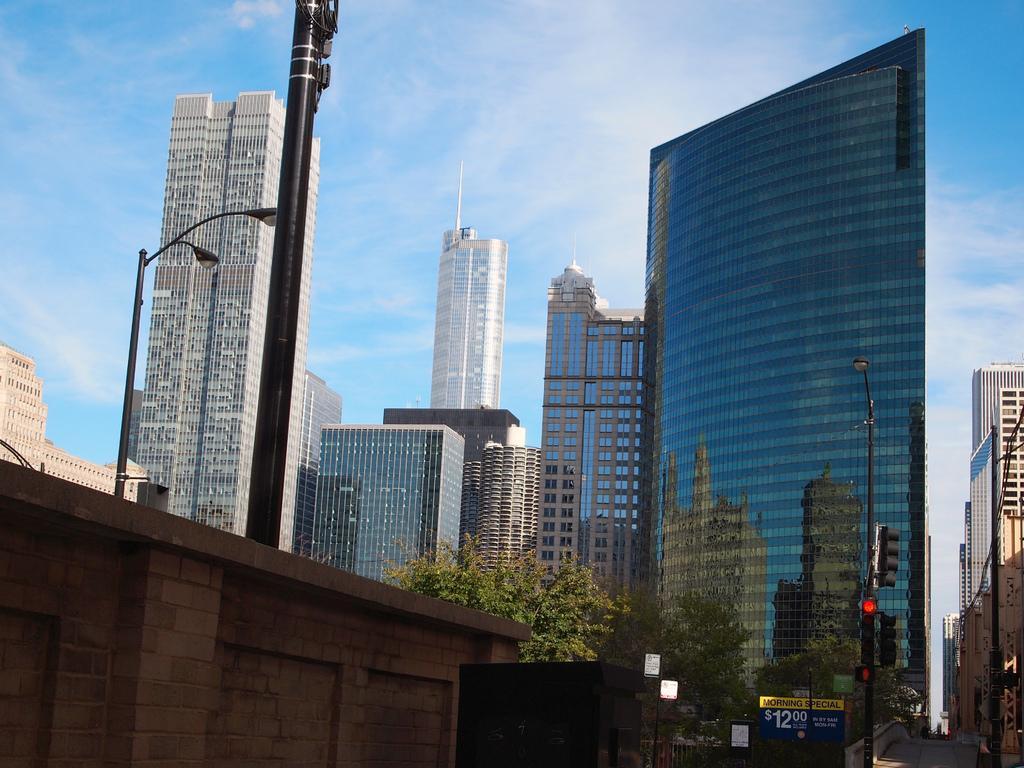Could you give a brief overview of what you see in this image? In this picture I can see there is a road and there are poles with traffic lights and there are trees and buildings and they have glass windows, there is a wall into left and the sky is clear. 